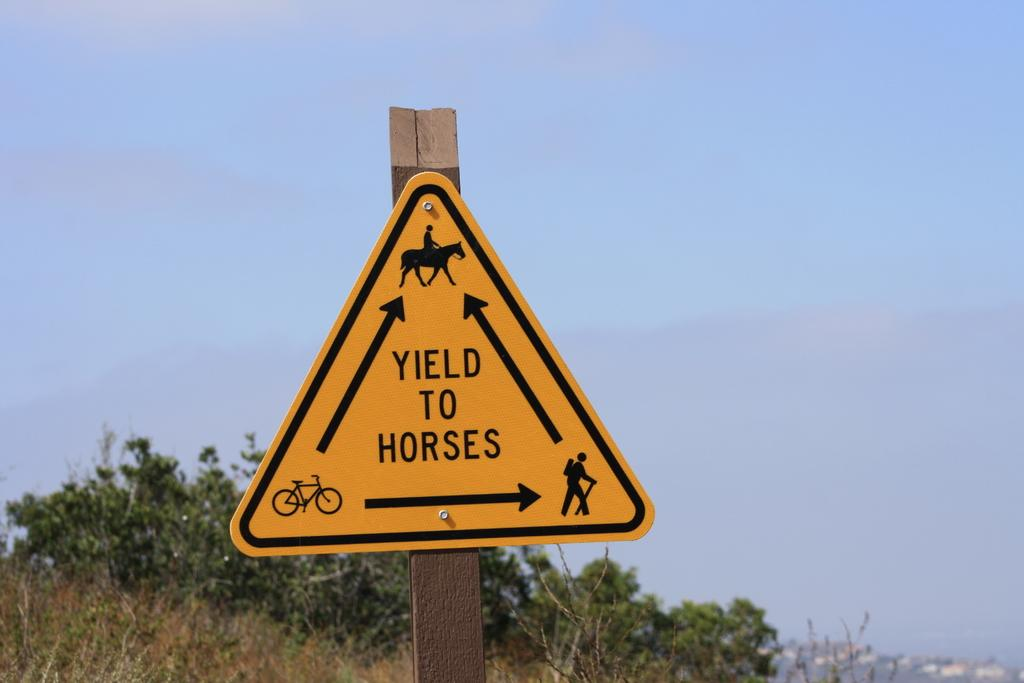<image>
Summarize the visual content of the image. A triangle sign that tells you to yield to horses while showing hiker, bike and horse 